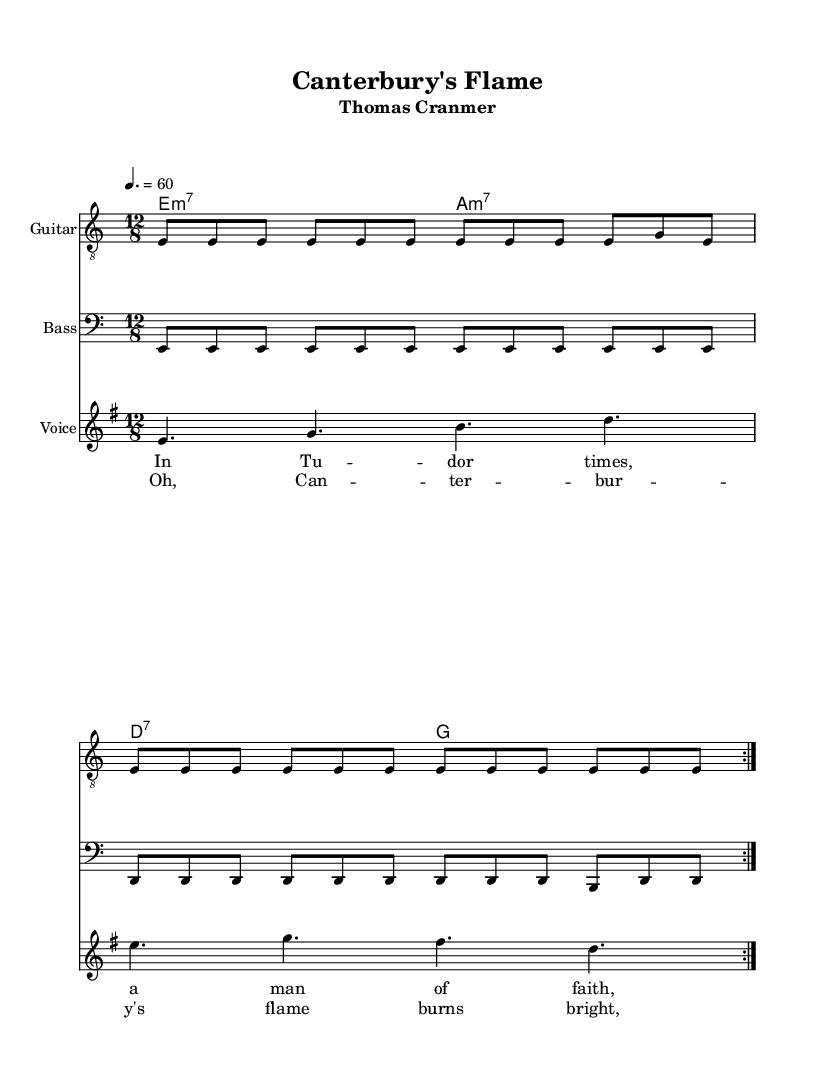What is the key signature of this music? The key signature is E minor, which has one sharp (F#). It can be identified at the beginning of the staff where the sharp is placed on the F line.
Answer: E minor What is the time signature of this piece? The time signature is 12/8, indicated at the beginning of the score. This means there are twelve eighth notes in each measure.
Answer: 12/8 What is the tempo marking for this piece? The tempo marking is 4 equals 60, which specifies that there are 60 beats per minute, approximating a moderate tempo. This is commonly placed at the start of the sheet music.
Answer: 60 How many volta repeats are indicated in the melody section? There are two volta repeats indicated above the melody line. This means the melody will be played twice before moving on.
Answer: 2 What type of harmonies are used in this piece? The harmonies used are minor 7th and dominant 7th chords (E minor 7 and A minor 7) followed by D7 and G chords. These chords fit well within the blues genre's structure.
Answer: Minor 7th and dominant 7th What is the subject of the lyrics in this ballad? The lyrics narrate the story of Thomas Cranmer, addressing his influence and the struggles faced during Tudor times. This thematic content is a common characteristic of electric blues ballads.
Answer: Thomas Cranmer 